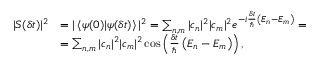Convert formula to latex. <formula><loc_0><loc_0><loc_500><loc_500>{ \begin{array} { r l } { | S ( \delta t ) | ^ { 2 } } & { = | \left \langle \psi ( 0 ) | \psi ( \delta t ) \right \rangle | ^ { 2 } = \sum _ { n , m } | c _ { n } | ^ { 2 } | c _ { m } | ^ { 2 } e ^ { - i { \frac { \delta t } { } } \left ( E _ { n } - E _ { m } \right ) } = } \\ & { = \sum _ { n , m } | c _ { n } | ^ { 2 } | c _ { m } | ^ { 2 } \cos \left ( { \frac { \delta t } { } } \left ( E _ { n } - E _ { m } \right ) \right ) , } \end{array} }</formula> 